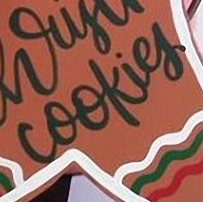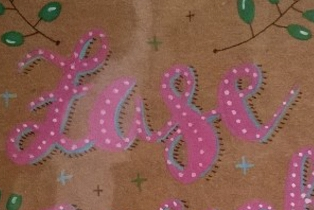Read the text content from these images in order, separated by a semicolon. cookies; Lase 